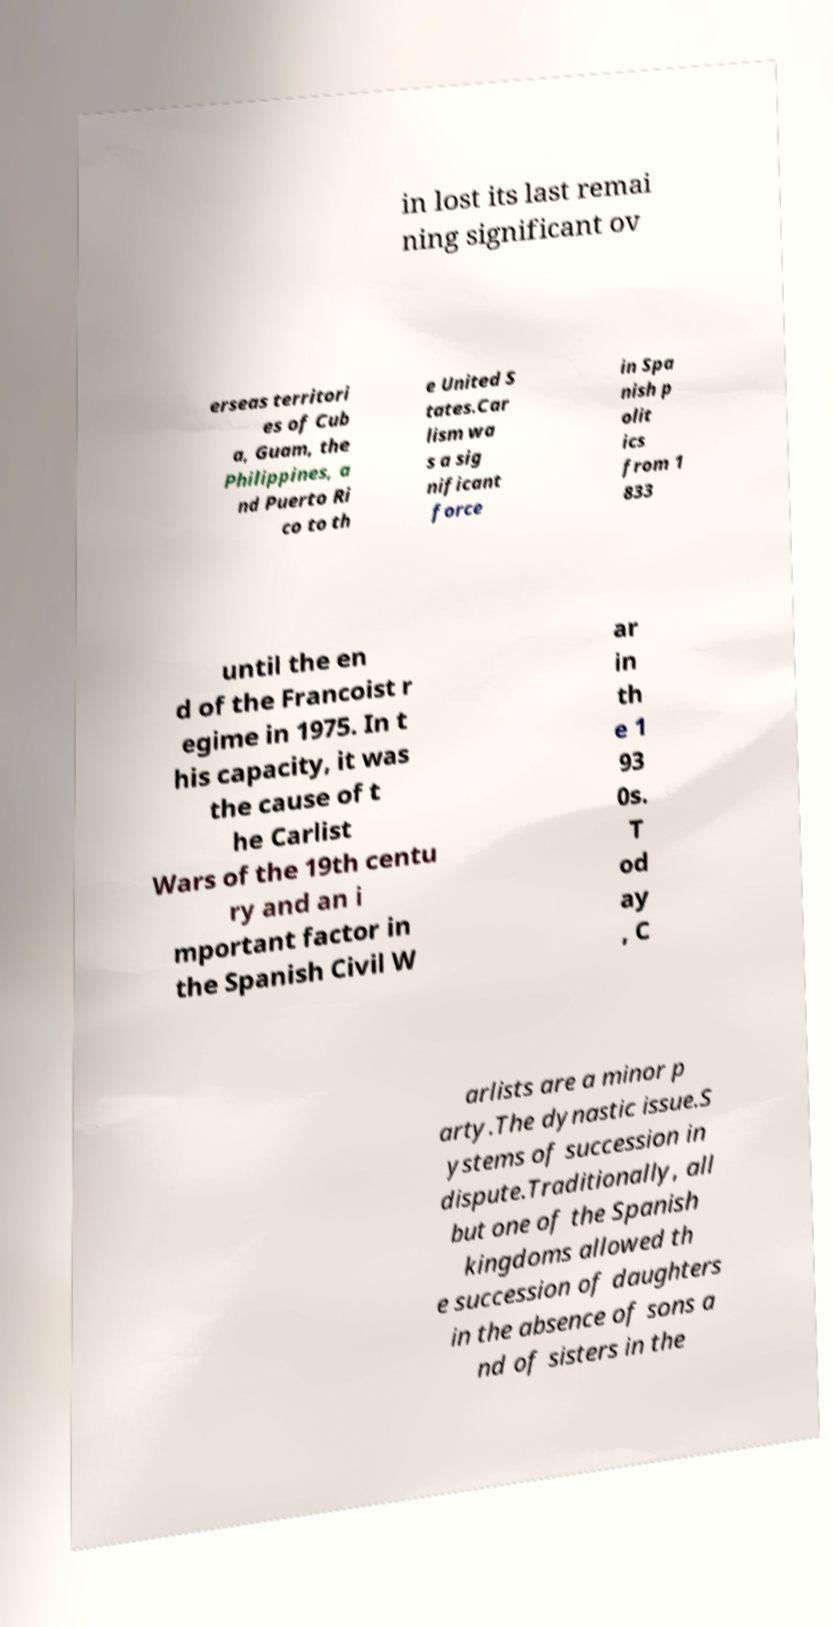Could you extract and type out the text from this image? in lost its last remai ning significant ov erseas territori es of Cub a, Guam, the Philippines, a nd Puerto Ri co to th e United S tates.Car lism wa s a sig nificant force in Spa nish p olit ics from 1 833 until the en d of the Francoist r egime in 1975. In t his capacity, it was the cause of t he Carlist Wars of the 19th centu ry and an i mportant factor in the Spanish Civil W ar in th e 1 93 0s. T od ay , C arlists are a minor p arty.The dynastic issue.S ystems of succession in dispute.Traditionally, all but one of the Spanish kingdoms allowed th e succession of daughters in the absence of sons a nd of sisters in the 